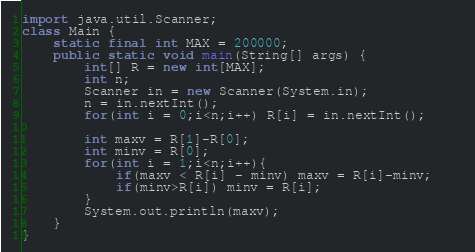Convert code to text. <code><loc_0><loc_0><loc_500><loc_500><_Java_>import java.util.Scanner;
class Main {
	static final int MAX = 200000;
	public static void main(String[] args) {
		int[] R = new int[MAX];
		int n;
		Scanner in = new Scanner(System.in);
		n = in.nextInt();
		for(int i = 0;i<n;i++) R[i] = in.nextInt();
		
		int maxv = R[1]-R[0];
		int minv = R[0];
		for(int i = 1;i<n;i++){
			if(maxv < R[i] - minv) maxv = R[i]-minv;	
			if(minv>R[i]) minv = R[i];
		}
		System.out.println(maxv);
	}
}</code> 